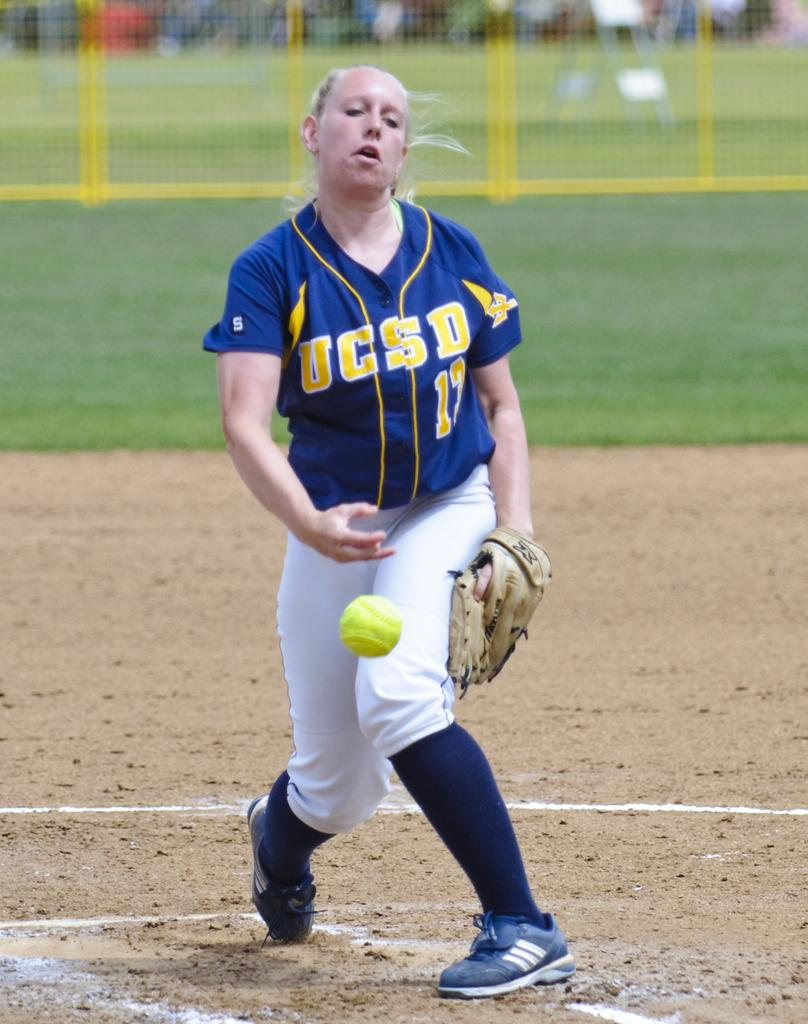<image>
Describe the image concisely. The pitcher for the UCSD softball team throws a pitch to a batter. 